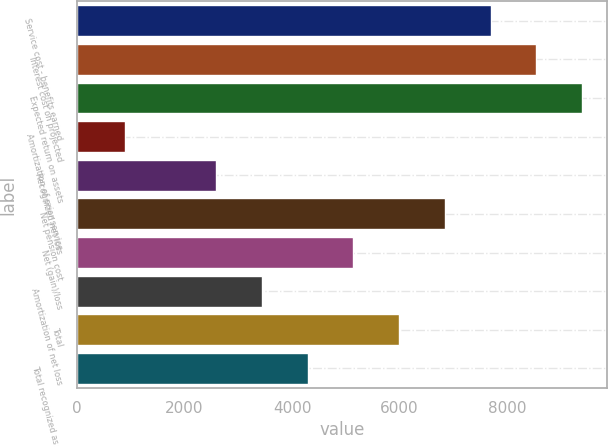Convert chart to OTSL. <chart><loc_0><loc_0><loc_500><loc_500><bar_chart><fcel>Service cost - benefits earned<fcel>Interest cost on projected<fcel>Expected return on assets<fcel>Amortization of prior service<fcel>Recognized net loss<fcel>Net pension cost<fcel>Net (gain)/loss<fcel>Amortization of net loss<fcel>Total<fcel>Total recognized as net<nl><fcel>7692.1<fcel>8543<fcel>9393.9<fcel>884.9<fcel>2586.7<fcel>6841.2<fcel>5139.4<fcel>3437.6<fcel>5990.3<fcel>4288.5<nl></chart> 